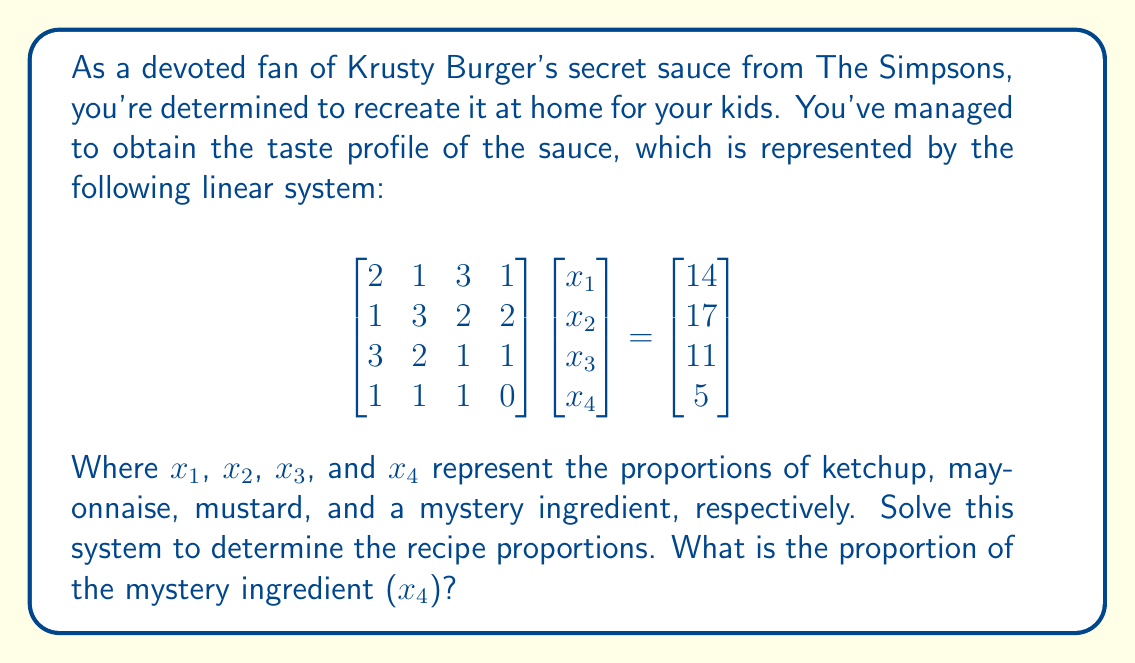Give your solution to this math problem. To solve this linear system, we'll use Gaussian elimination to transform the augmented matrix into row echelon form:

1) Start with the augmented matrix:
   $$\begin{bmatrix}
   2 & 1 & 3 & 1 & | & 14 \\
   1 & 3 & 2 & 2 & | & 17 \\
   3 & 2 & 1 & 1 & | & 11 \\
   1 & 1 & 1 & 0 & | & 5
   \end{bmatrix}$$

2) Subtract row 1 from row 3:
   $$\begin{bmatrix}
   2 & 1 & 3 & 1 & | & 14 \\
   1 & 3 & 2 & 2 & | & 17 \\
   1 & 1 & -2 & 0 & | & -3 \\
   1 & 1 & 1 & 0 & | & 5
   \end{bmatrix}$$

3) Subtract row 1 from row 2:
   $$\begin{bmatrix}
   2 & 1 & 3 & 1 & | & 14 \\
   -1 & 2 & -1 & 1 & | & 3 \\
   1 & 1 & -2 & 0 & | & -3 \\
   1 & 1 & 1 & 0 & | & 5
   \end{bmatrix}$$

4) Add row 2 to row 1:
   $$\begin{bmatrix}
   1 & 3 & 2 & 2 & | & 17 \\
   -1 & 2 & -1 & 1 & | & 3 \\
   1 & 1 & -2 & 0 & | & -3 \\
   1 & 1 & 1 & 0 & | & 5
   \end{bmatrix}$$

5) Add row 1 to row 2:
   $$\begin{bmatrix}
   1 & 3 & 2 & 2 & | & 17 \\
   0 & 5 & 1 & 3 & | & 20 \\
   1 & 1 & -2 & 0 & | & -3 \\
   1 & 1 & 1 & 0 & | & 5
   \end{bmatrix}$$

6) Subtract row 1 from row 3 and row 4:
   $$\begin{bmatrix}
   1 & 3 & 2 & 2 & | & 17 \\
   0 & 5 & 1 & 3 & | & 20 \\
   0 & -2 & -4 & -2 & | & -20 \\
   0 & -2 & -1 & -2 & | & -12
   \end{bmatrix}$$

7) Add 2/5 of row 2 to row 3 and row 4:
   $$\begin{bmatrix}
   1 & 3 & 2 & 2 & | & 17 \\
   0 & 5 & 1 & 3 & | & 20 \\
   0 & 0 & -3.6 & -0.8 & | & -12 \\
   0 & 0 & -0.6 & -0.8 & | & -4
   \end{bmatrix}$$

8) Multiply row 3 by -5/18 and row 4 by -5/3:
   $$\begin{bmatrix}
   1 & 3 & 2 & 2 & | & 17 \\
   0 & 5 & 1 & 3 & | & 20 \\
   0 & 0 & 1 & 2/9 & | & 10/3 \\
   0 & 0 & 1 & 4/3 & | & 20/3
   \end{bmatrix}$$

9) Subtract row 3 from row 4:
   $$\begin{bmatrix}
   1 & 3 & 2 & 2 & | & 17 \\
   0 & 5 & 1 & 3 & | & 20 \\
   0 & 0 & 1 & 2/9 & | & 10/3 \\
   0 & 0 & 0 & 10/9 & | & 10/3
   \end{bmatrix}$$

Now we have the system in row echelon form. We can solve for $x_4$ directly:

$\frac{10}{9}x_4 = \frac{10}{3}$

$x_4 = \frac{10}{3} \cdot \frac{9}{10} = 3$

Therefore, the proportion of the mystery ingredient ($x_4$) is 3.
Answer: 3 